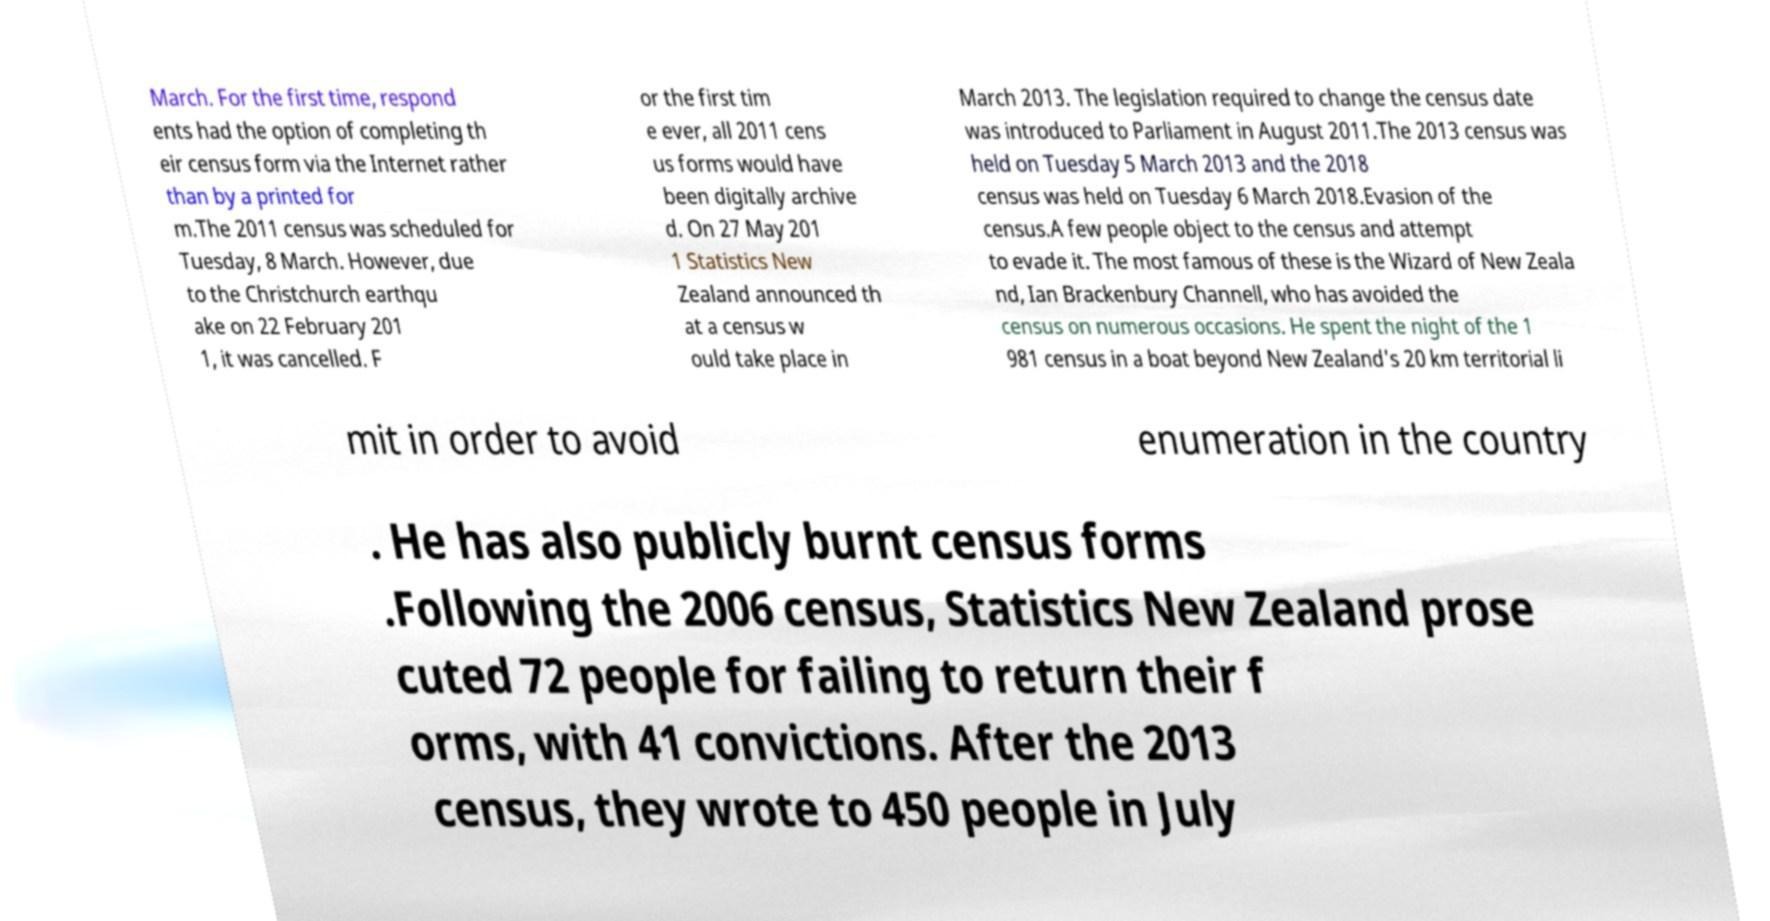Can you read and provide the text displayed in the image?This photo seems to have some interesting text. Can you extract and type it out for me? March. For the first time, respond ents had the option of completing th eir census form via the Internet rather than by a printed for m.The 2011 census was scheduled for Tuesday, 8 March. However, due to the Christchurch earthqu ake on 22 February 201 1, it was cancelled. F or the first tim e ever, all 2011 cens us forms would have been digitally archive d. On 27 May 201 1 Statistics New Zealand announced th at a census w ould take place in March 2013. The legislation required to change the census date was introduced to Parliament in August 2011.The 2013 census was held on Tuesday 5 March 2013 and the 2018 census was held on Tuesday 6 March 2018.Evasion of the census.A few people object to the census and attempt to evade it. The most famous of these is the Wizard of New Zeala nd, Ian Brackenbury Channell, who has avoided the census on numerous occasions. He spent the night of the 1 981 census in a boat beyond New Zealand's 20 km territorial li mit in order to avoid enumeration in the country . He has also publicly burnt census forms .Following the 2006 census, Statistics New Zealand prose cuted 72 people for failing to return their f orms, with 41 convictions. After the 2013 census, they wrote to 450 people in July 